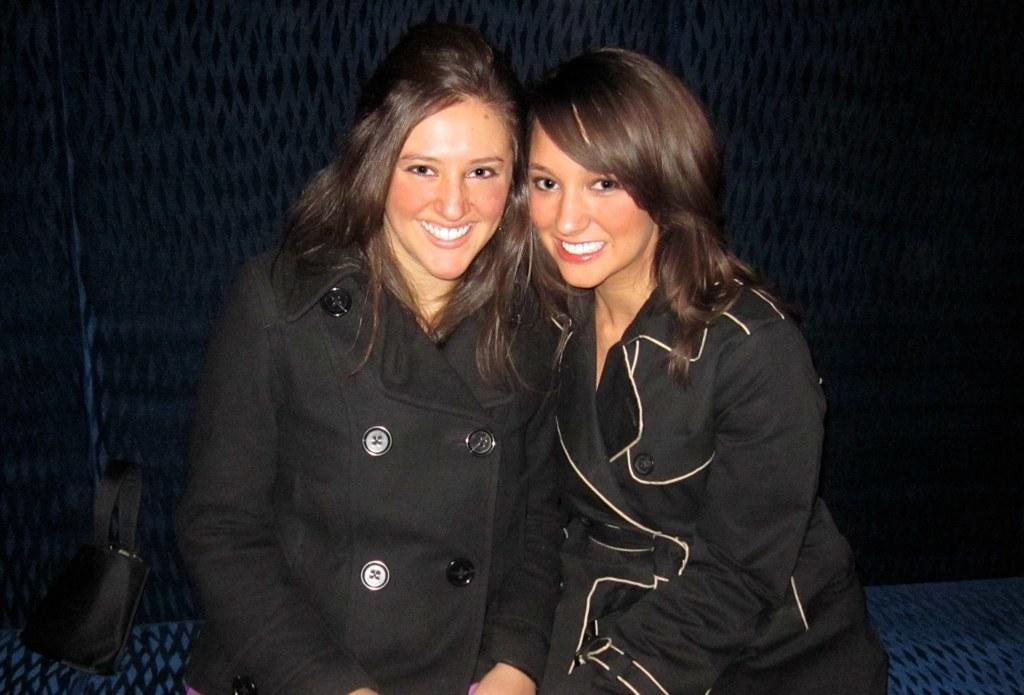How many people are in the image? There are two women in the image. What are the women doing in the image? The women are sitting on a surface. What can be seen in the background of the image? There is a bag and a wall in the background of the image. What type of nut is being used to power the system in the image? There is no system or nut present in the image. 